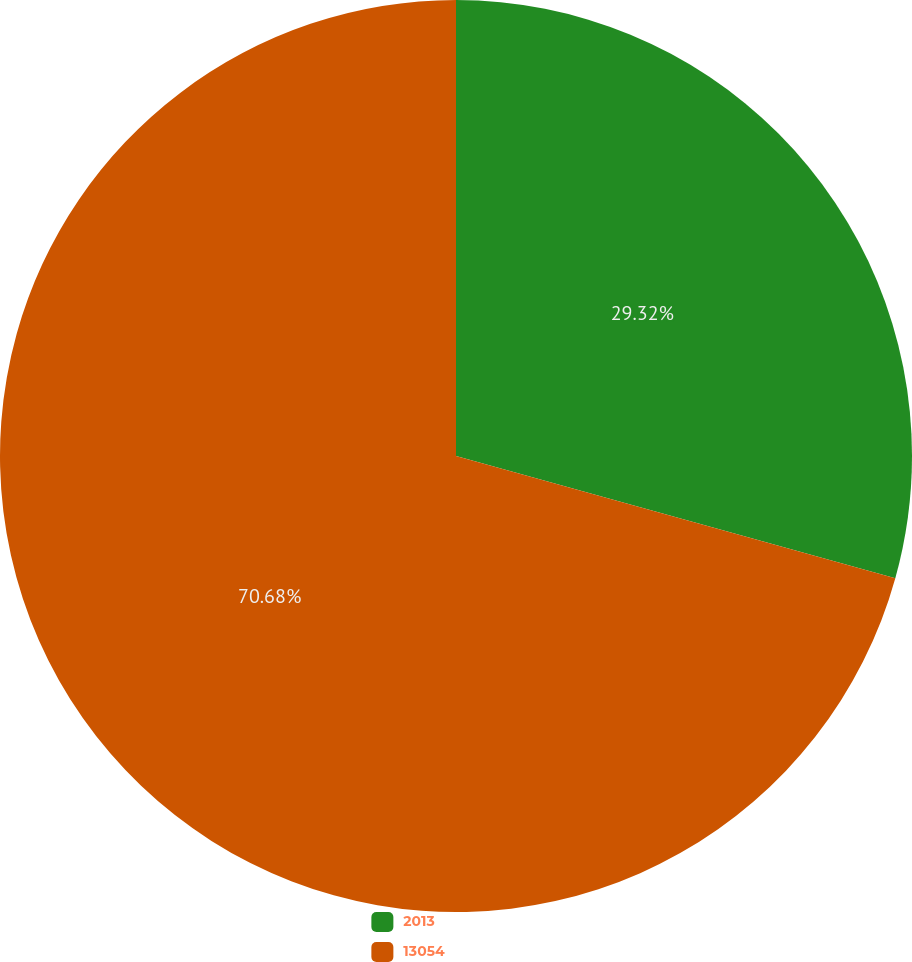Convert chart to OTSL. <chart><loc_0><loc_0><loc_500><loc_500><pie_chart><fcel>2013<fcel>13054<nl><fcel>29.32%<fcel>70.68%<nl></chart> 